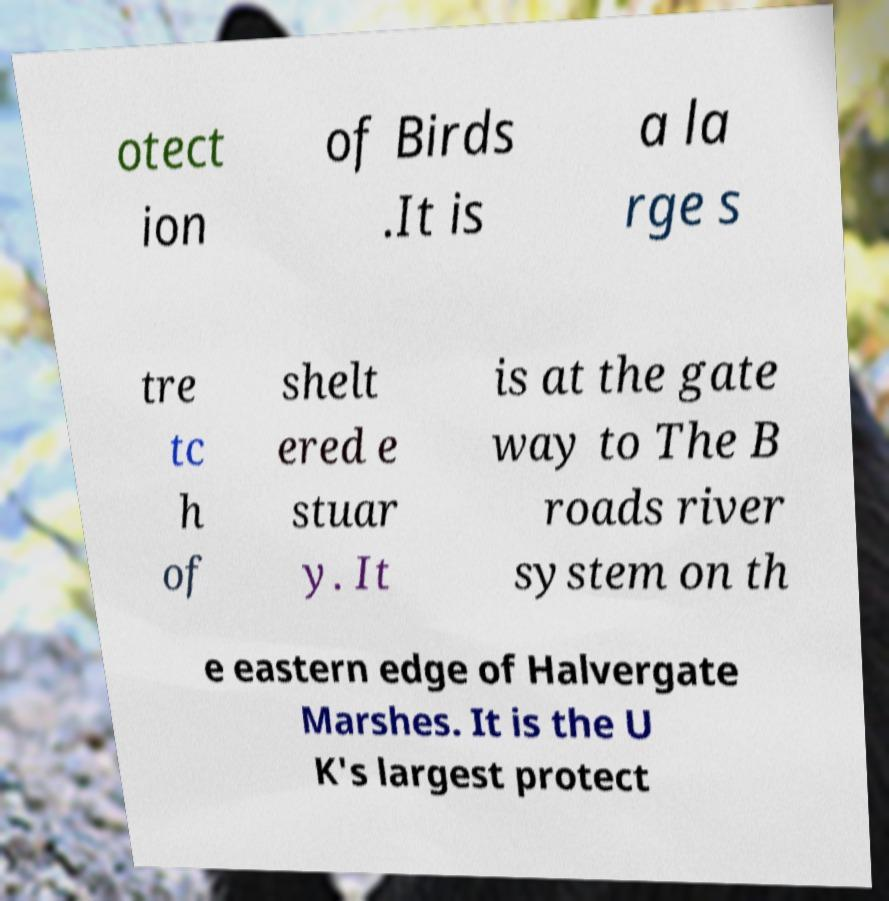Can you accurately transcribe the text from the provided image for me? otect ion of Birds .It is a la rge s tre tc h of shelt ered e stuar y. It is at the gate way to The B roads river system on th e eastern edge of Halvergate Marshes. It is the U K's largest protect 